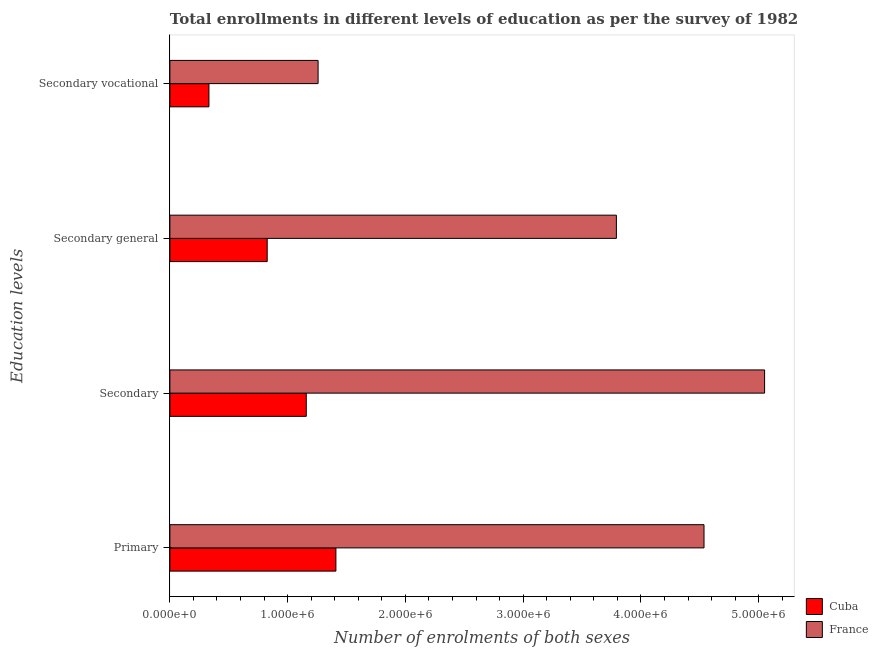How many groups of bars are there?
Your answer should be very brief. 4. Are the number of bars on each tick of the Y-axis equal?
Give a very brief answer. Yes. How many bars are there on the 4th tick from the top?
Provide a succinct answer. 2. How many bars are there on the 4th tick from the bottom?
Ensure brevity in your answer.  2. What is the label of the 3rd group of bars from the top?
Keep it short and to the point. Secondary. What is the number of enrolments in secondary education in France?
Offer a terse response. 5.05e+06. Across all countries, what is the maximum number of enrolments in secondary education?
Ensure brevity in your answer.  5.05e+06. Across all countries, what is the minimum number of enrolments in primary education?
Provide a succinct answer. 1.41e+06. In which country was the number of enrolments in secondary vocational education minimum?
Ensure brevity in your answer.  Cuba. What is the total number of enrolments in secondary education in the graph?
Ensure brevity in your answer.  6.21e+06. What is the difference between the number of enrolments in secondary vocational education in Cuba and that in France?
Provide a short and direct response. -9.27e+05. What is the difference between the number of enrolments in secondary vocational education in France and the number of enrolments in primary education in Cuba?
Keep it short and to the point. -1.51e+05. What is the average number of enrolments in primary education per country?
Your response must be concise. 2.97e+06. What is the difference between the number of enrolments in secondary general education and number of enrolments in secondary education in Cuba?
Make the answer very short. -3.32e+05. In how many countries, is the number of enrolments in secondary general education greater than 200000 ?
Provide a short and direct response. 2. What is the ratio of the number of enrolments in secondary education in Cuba to that in France?
Ensure brevity in your answer.  0.23. Is the number of enrolments in secondary general education in France less than that in Cuba?
Provide a succinct answer. No. What is the difference between the highest and the second highest number of enrolments in secondary education?
Provide a short and direct response. 3.89e+06. What is the difference between the highest and the lowest number of enrolments in secondary general education?
Offer a terse response. 2.97e+06. Is it the case that in every country, the sum of the number of enrolments in secondary vocational education and number of enrolments in primary education is greater than the sum of number of enrolments in secondary general education and number of enrolments in secondary education?
Keep it short and to the point. No. What does the 2nd bar from the top in Secondary represents?
Ensure brevity in your answer.  Cuba. What does the 1st bar from the bottom in Primary represents?
Ensure brevity in your answer.  Cuba. How many bars are there?
Your response must be concise. 8. How many countries are there in the graph?
Keep it short and to the point. 2. What is the difference between two consecutive major ticks on the X-axis?
Give a very brief answer. 1.00e+06. Are the values on the major ticks of X-axis written in scientific E-notation?
Your answer should be very brief. Yes. Does the graph contain grids?
Keep it short and to the point. No. Where does the legend appear in the graph?
Ensure brevity in your answer.  Bottom right. How many legend labels are there?
Your response must be concise. 2. How are the legend labels stacked?
Provide a short and direct response. Vertical. What is the title of the graph?
Keep it short and to the point. Total enrollments in different levels of education as per the survey of 1982. What is the label or title of the X-axis?
Make the answer very short. Number of enrolments of both sexes. What is the label or title of the Y-axis?
Offer a terse response. Education levels. What is the Number of enrolments of both sexes in Cuba in Primary?
Your response must be concise. 1.41e+06. What is the Number of enrolments of both sexes of France in Primary?
Your answer should be very brief. 4.54e+06. What is the Number of enrolments of both sexes of Cuba in Secondary?
Offer a terse response. 1.16e+06. What is the Number of enrolments of both sexes of France in Secondary?
Keep it short and to the point. 5.05e+06. What is the Number of enrolments of both sexes in Cuba in Secondary general?
Your answer should be very brief. 8.26e+05. What is the Number of enrolments of both sexes of France in Secondary general?
Make the answer very short. 3.79e+06. What is the Number of enrolments of both sexes in Cuba in Secondary vocational?
Offer a very short reply. 3.32e+05. What is the Number of enrolments of both sexes in France in Secondary vocational?
Keep it short and to the point. 1.26e+06. Across all Education levels, what is the maximum Number of enrolments of both sexes in Cuba?
Keep it short and to the point. 1.41e+06. Across all Education levels, what is the maximum Number of enrolments of both sexes of France?
Your answer should be compact. 5.05e+06. Across all Education levels, what is the minimum Number of enrolments of both sexes in Cuba?
Give a very brief answer. 3.32e+05. Across all Education levels, what is the minimum Number of enrolments of both sexes of France?
Offer a terse response. 1.26e+06. What is the total Number of enrolments of both sexes of Cuba in the graph?
Keep it short and to the point. 3.73e+06. What is the total Number of enrolments of both sexes in France in the graph?
Keep it short and to the point. 1.46e+07. What is the difference between the Number of enrolments of both sexes in Cuba in Primary and that in Secondary?
Provide a short and direct response. 2.52e+05. What is the difference between the Number of enrolments of both sexes of France in Primary and that in Secondary?
Ensure brevity in your answer.  -5.14e+05. What is the difference between the Number of enrolments of both sexes of Cuba in Primary and that in Secondary general?
Ensure brevity in your answer.  5.83e+05. What is the difference between the Number of enrolments of both sexes in France in Primary and that in Secondary general?
Make the answer very short. 7.44e+05. What is the difference between the Number of enrolments of both sexes in Cuba in Primary and that in Secondary vocational?
Keep it short and to the point. 1.08e+06. What is the difference between the Number of enrolments of both sexes of France in Primary and that in Secondary vocational?
Offer a terse response. 3.28e+06. What is the difference between the Number of enrolments of both sexes in Cuba in Secondary and that in Secondary general?
Your response must be concise. 3.32e+05. What is the difference between the Number of enrolments of both sexes of France in Secondary and that in Secondary general?
Offer a very short reply. 1.26e+06. What is the difference between the Number of enrolments of both sexes in Cuba in Secondary and that in Secondary vocational?
Provide a short and direct response. 8.26e+05. What is the difference between the Number of enrolments of both sexes in France in Secondary and that in Secondary vocational?
Offer a terse response. 3.79e+06. What is the difference between the Number of enrolments of both sexes in Cuba in Secondary general and that in Secondary vocational?
Your answer should be very brief. 4.95e+05. What is the difference between the Number of enrolments of both sexes in France in Secondary general and that in Secondary vocational?
Make the answer very short. 2.53e+06. What is the difference between the Number of enrolments of both sexes in Cuba in Primary and the Number of enrolments of both sexes in France in Secondary?
Offer a very short reply. -3.64e+06. What is the difference between the Number of enrolments of both sexes in Cuba in Primary and the Number of enrolments of both sexes in France in Secondary general?
Make the answer very short. -2.38e+06. What is the difference between the Number of enrolments of both sexes in Cuba in Primary and the Number of enrolments of both sexes in France in Secondary vocational?
Make the answer very short. 1.51e+05. What is the difference between the Number of enrolments of both sexes of Cuba in Secondary and the Number of enrolments of both sexes of France in Secondary general?
Offer a very short reply. -2.63e+06. What is the difference between the Number of enrolments of both sexes in Cuba in Secondary and the Number of enrolments of both sexes in France in Secondary vocational?
Ensure brevity in your answer.  -1.00e+05. What is the difference between the Number of enrolments of both sexes of Cuba in Secondary general and the Number of enrolments of both sexes of France in Secondary vocational?
Keep it short and to the point. -4.32e+05. What is the average Number of enrolments of both sexes in Cuba per Education levels?
Your answer should be very brief. 9.32e+05. What is the average Number of enrolments of both sexes in France per Education levels?
Offer a terse response. 3.66e+06. What is the difference between the Number of enrolments of both sexes of Cuba and Number of enrolments of both sexes of France in Primary?
Make the answer very short. -3.13e+06. What is the difference between the Number of enrolments of both sexes of Cuba and Number of enrolments of both sexes of France in Secondary?
Give a very brief answer. -3.89e+06. What is the difference between the Number of enrolments of both sexes in Cuba and Number of enrolments of both sexes in France in Secondary general?
Keep it short and to the point. -2.97e+06. What is the difference between the Number of enrolments of both sexes of Cuba and Number of enrolments of both sexes of France in Secondary vocational?
Provide a short and direct response. -9.27e+05. What is the ratio of the Number of enrolments of both sexes of Cuba in Primary to that in Secondary?
Your answer should be very brief. 1.22. What is the ratio of the Number of enrolments of both sexes in France in Primary to that in Secondary?
Make the answer very short. 0.9. What is the ratio of the Number of enrolments of both sexes of Cuba in Primary to that in Secondary general?
Your response must be concise. 1.71. What is the ratio of the Number of enrolments of both sexes of France in Primary to that in Secondary general?
Offer a very short reply. 1.2. What is the ratio of the Number of enrolments of both sexes of Cuba in Primary to that in Secondary vocational?
Provide a succinct answer. 4.25. What is the ratio of the Number of enrolments of both sexes of France in Primary to that in Secondary vocational?
Provide a succinct answer. 3.6. What is the ratio of the Number of enrolments of both sexes of Cuba in Secondary to that in Secondary general?
Provide a short and direct response. 1.4. What is the ratio of the Number of enrolments of both sexes in France in Secondary to that in Secondary general?
Ensure brevity in your answer.  1.33. What is the ratio of the Number of enrolments of both sexes in Cuba in Secondary to that in Secondary vocational?
Your answer should be very brief. 3.49. What is the ratio of the Number of enrolments of both sexes in France in Secondary to that in Secondary vocational?
Your answer should be very brief. 4.01. What is the ratio of the Number of enrolments of both sexes in Cuba in Secondary general to that in Secondary vocational?
Offer a very short reply. 2.49. What is the ratio of the Number of enrolments of both sexes of France in Secondary general to that in Secondary vocational?
Keep it short and to the point. 3.01. What is the difference between the highest and the second highest Number of enrolments of both sexes of Cuba?
Provide a succinct answer. 2.52e+05. What is the difference between the highest and the second highest Number of enrolments of both sexes in France?
Give a very brief answer. 5.14e+05. What is the difference between the highest and the lowest Number of enrolments of both sexes of Cuba?
Your answer should be very brief. 1.08e+06. What is the difference between the highest and the lowest Number of enrolments of both sexes in France?
Give a very brief answer. 3.79e+06. 